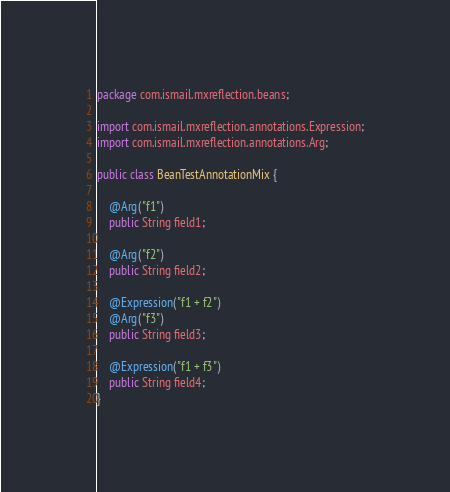<code> <loc_0><loc_0><loc_500><loc_500><_Java_>package com.ismail.mxreflection.beans;

import com.ismail.mxreflection.annotations.Expression;
import com.ismail.mxreflection.annotations.Arg;

public class BeanTestAnnotationMix {

    @Arg("f1")
    public String field1;

    @Arg("f2")
    public String field2;

    @Expression("f1 + f2")
    @Arg("f3")
    public String field3;

    @Expression("f1 + f3")
    public String field4;
}
</code> 